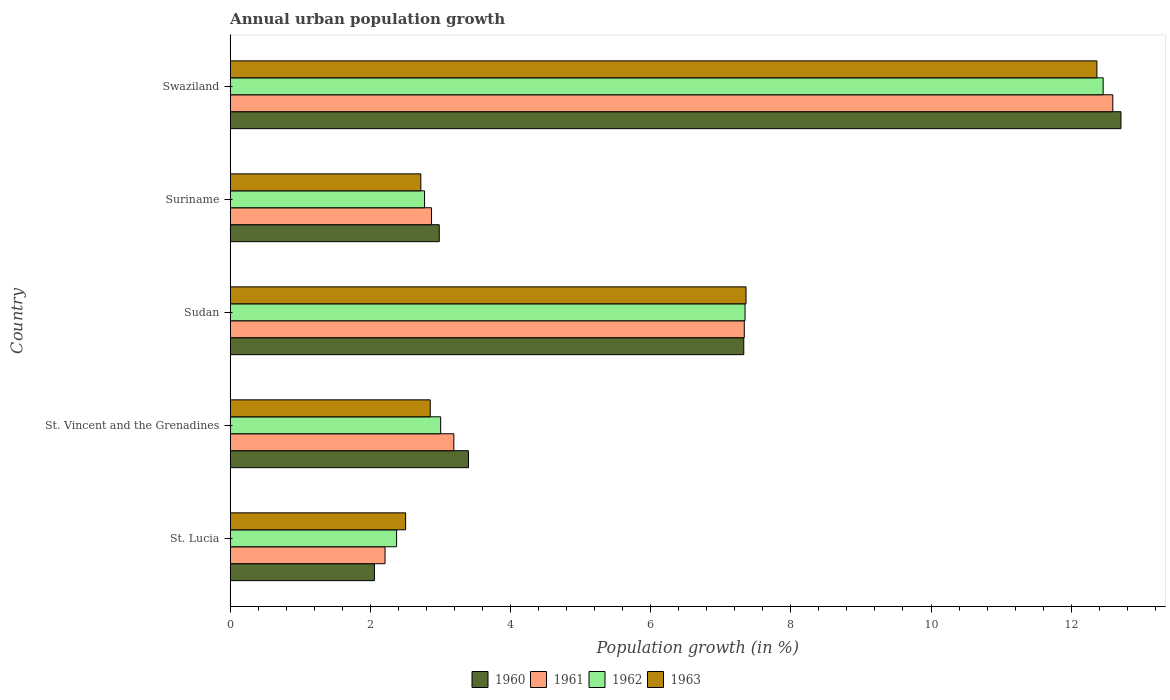How many different coloured bars are there?
Your response must be concise. 4. Are the number of bars per tick equal to the number of legend labels?
Offer a very short reply. Yes. Are the number of bars on each tick of the Y-axis equal?
Your answer should be very brief. Yes. How many bars are there on the 3rd tick from the bottom?
Offer a terse response. 4. What is the label of the 2nd group of bars from the top?
Your response must be concise. Suriname. What is the percentage of urban population growth in 1961 in St. Lucia?
Offer a very short reply. 2.21. Across all countries, what is the maximum percentage of urban population growth in 1960?
Your response must be concise. 12.71. Across all countries, what is the minimum percentage of urban population growth in 1960?
Provide a short and direct response. 2.06. In which country was the percentage of urban population growth in 1961 maximum?
Provide a short and direct response. Swaziland. In which country was the percentage of urban population growth in 1961 minimum?
Offer a terse response. St. Lucia. What is the total percentage of urban population growth in 1960 in the graph?
Your answer should be very brief. 28.48. What is the difference between the percentage of urban population growth in 1962 in Suriname and that in Swaziland?
Keep it short and to the point. -9.68. What is the difference between the percentage of urban population growth in 1962 in St. Vincent and the Grenadines and the percentage of urban population growth in 1963 in Swaziland?
Your answer should be compact. -9.36. What is the average percentage of urban population growth in 1960 per country?
Provide a short and direct response. 5.7. What is the difference between the percentage of urban population growth in 1961 and percentage of urban population growth in 1963 in St. Lucia?
Your answer should be compact. -0.29. What is the ratio of the percentage of urban population growth in 1961 in St. Vincent and the Grenadines to that in Sudan?
Offer a very short reply. 0.44. Is the percentage of urban population growth in 1963 in Sudan less than that in Suriname?
Your answer should be compact. No. What is the difference between the highest and the second highest percentage of urban population growth in 1963?
Offer a very short reply. 5.01. What is the difference between the highest and the lowest percentage of urban population growth in 1963?
Your answer should be compact. 9.86. In how many countries, is the percentage of urban population growth in 1961 greater than the average percentage of urban population growth in 1961 taken over all countries?
Provide a short and direct response. 2. Is the sum of the percentage of urban population growth in 1962 in St. Lucia and Sudan greater than the maximum percentage of urban population growth in 1963 across all countries?
Your response must be concise. No. Is it the case that in every country, the sum of the percentage of urban population growth in 1963 and percentage of urban population growth in 1962 is greater than the sum of percentage of urban population growth in 1961 and percentage of urban population growth in 1960?
Your answer should be very brief. No. What does the 4th bar from the top in Sudan represents?
Give a very brief answer. 1960. How many bars are there?
Give a very brief answer. 20. Are all the bars in the graph horizontal?
Make the answer very short. Yes. How many countries are there in the graph?
Offer a very short reply. 5. Where does the legend appear in the graph?
Your response must be concise. Bottom center. What is the title of the graph?
Provide a short and direct response. Annual urban population growth. Does "1980" appear as one of the legend labels in the graph?
Offer a terse response. No. What is the label or title of the X-axis?
Your response must be concise. Population growth (in %). What is the Population growth (in %) in 1960 in St. Lucia?
Offer a terse response. 2.06. What is the Population growth (in %) in 1961 in St. Lucia?
Offer a terse response. 2.21. What is the Population growth (in %) in 1962 in St. Lucia?
Ensure brevity in your answer.  2.37. What is the Population growth (in %) in 1963 in St. Lucia?
Provide a succinct answer. 2.5. What is the Population growth (in %) of 1960 in St. Vincent and the Grenadines?
Your response must be concise. 3.4. What is the Population growth (in %) in 1961 in St. Vincent and the Grenadines?
Make the answer very short. 3.19. What is the Population growth (in %) in 1962 in St. Vincent and the Grenadines?
Make the answer very short. 3. What is the Population growth (in %) of 1963 in St. Vincent and the Grenadines?
Ensure brevity in your answer.  2.85. What is the Population growth (in %) in 1960 in Sudan?
Your answer should be compact. 7.33. What is the Population growth (in %) of 1961 in Sudan?
Make the answer very short. 7.34. What is the Population growth (in %) of 1962 in Sudan?
Give a very brief answer. 7.35. What is the Population growth (in %) in 1963 in Sudan?
Give a very brief answer. 7.36. What is the Population growth (in %) in 1960 in Suriname?
Your answer should be compact. 2.98. What is the Population growth (in %) of 1961 in Suriname?
Make the answer very short. 2.87. What is the Population growth (in %) in 1962 in Suriname?
Offer a terse response. 2.77. What is the Population growth (in %) in 1963 in Suriname?
Your answer should be very brief. 2.72. What is the Population growth (in %) in 1960 in Swaziland?
Offer a terse response. 12.71. What is the Population growth (in %) in 1961 in Swaziland?
Offer a very short reply. 12.59. What is the Population growth (in %) of 1962 in Swaziland?
Give a very brief answer. 12.46. What is the Population growth (in %) in 1963 in Swaziland?
Your response must be concise. 12.37. Across all countries, what is the maximum Population growth (in %) in 1960?
Your response must be concise. 12.71. Across all countries, what is the maximum Population growth (in %) of 1961?
Ensure brevity in your answer.  12.59. Across all countries, what is the maximum Population growth (in %) in 1962?
Make the answer very short. 12.46. Across all countries, what is the maximum Population growth (in %) of 1963?
Provide a short and direct response. 12.37. Across all countries, what is the minimum Population growth (in %) of 1960?
Offer a very short reply. 2.06. Across all countries, what is the minimum Population growth (in %) of 1961?
Ensure brevity in your answer.  2.21. Across all countries, what is the minimum Population growth (in %) of 1962?
Your response must be concise. 2.37. Across all countries, what is the minimum Population growth (in %) in 1963?
Ensure brevity in your answer.  2.5. What is the total Population growth (in %) of 1960 in the graph?
Provide a succinct answer. 28.48. What is the total Population growth (in %) of 1961 in the graph?
Your response must be concise. 28.2. What is the total Population growth (in %) in 1962 in the graph?
Keep it short and to the point. 27.95. What is the total Population growth (in %) of 1963 in the graph?
Give a very brief answer. 27.81. What is the difference between the Population growth (in %) in 1960 in St. Lucia and that in St. Vincent and the Grenadines?
Provide a succinct answer. -1.34. What is the difference between the Population growth (in %) of 1961 in St. Lucia and that in St. Vincent and the Grenadines?
Provide a succinct answer. -0.98. What is the difference between the Population growth (in %) of 1962 in St. Lucia and that in St. Vincent and the Grenadines?
Your answer should be compact. -0.63. What is the difference between the Population growth (in %) of 1963 in St. Lucia and that in St. Vincent and the Grenadines?
Your response must be concise. -0.35. What is the difference between the Population growth (in %) of 1960 in St. Lucia and that in Sudan?
Provide a short and direct response. -5.27. What is the difference between the Population growth (in %) in 1961 in St. Lucia and that in Sudan?
Keep it short and to the point. -5.13. What is the difference between the Population growth (in %) in 1962 in St. Lucia and that in Sudan?
Offer a terse response. -4.97. What is the difference between the Population growth (in %) of 1963 in St. Lucia and that in Sudan?
Make the answer very short. -4.86. What is the difference between the Population growth (in %) in 1960 in St. Lucia and that in Suriname?
Give a very brief answer. -0.93. What is the difference between the Population growth (in %) of 1961 in St. Lucia and that in Suriname?
Provide a succinct answer. -0.66. What is the difference between the Population growth (in %) in 1962 in St. Lucia and that in Suriname?
Your answer should be very brief. -0.4. What is the difference between the Population growth (in %) of 1963 in St. Lucia and that in Suriname?
Your response must be concise. -0.22. What is the difference between the Population growth (in %) in 1960 in St. Lucia and that in Swaziland?
Your response must be concise. -10.65. What is the difference between the Population growth (in %) in 1961 in St. Lucia and that in Swaziland?
Offer a very short reply. -10.38. What is the difference between the Population growth (in %) in 1962 in St. Lucia and that in Swaziland?
Offer a very short reply. -10.08. What is the difference between the Population growth (in %) in 1963 in St. Lucia and that in Swaziland?
Your answer should be very brief. -9.86. What is the difference between the Population growth (in %) of 1960 in St. Vincent and the Grenadines and that in Sudan?
Ensure brevity in your answer.  -3.93. What is the difference between the Population growth (in %) of 1961 in St. Vincent and the Grenadines and that in Sudan?
Offer a terse response. -4.14. What is the difference between the Population growth (in %) in 1962 in St. Vincent and the Grenadines and that in Sudan?
Provide a short and direct response. -4.34. What is the difference between the Population growth (in %) of 1963 in St. Vincent and the Grenadines and that in Sudan?
Your response must be concise. -4.51. What is the difference between the Population growth (in %) of 1960 in St. Vincent and the Grenadines and that in Suriname?
Provide a succinct answer. 0.42. What is the difference between the Population growth (in %) in 1961 in St. Vincent and the Grenadines and that in Suriname?
Provide a succinct answer. 0.32. What is the difference between the Population growth (in %) in 1962 in St. Vincent and the Grenadines and that in Suriname?
Provide a succinct answer. 0.23. What is the difference between the Population growth (in %) in 1963 in St. Vincent and the Grenadines and that in Suriname?
Give a very brief answer. 0.13. What is the difference between the Population growth (in %) in 1960 in St. Vincent and the Grenadines and that in Swaziland?
Provide a succinct answer. -9.31. What is the difference between the Population growth (in %) in 1961 in St. Vincent and the Grenadines and that in Swaziland?
Your response must be concise. -9.4. What is the difference between the Population growth (in %) of 1962 in St. Vincent and the Grenadines and that in Swaziland?
Your answer should be compact. -9.45. What is the difference between the Population growth (in %) in 1963 in St. Vincent and the Grenadines and that in Swaziland?
Your answer should be very brief. -9.51. What is the difference between the Population growth (in %) of 1960 in Sudan and that in Suriname?
Your answer should be compact. 4.35. What is the difference between the Population growth (in %) of 1961 in Sudan and that in Suriname?
Make the answer very short. 4.46. What is the difference between the Population growth (in %) of 1962 in Sudan and that in Suriname?
Give a very brief answer. 4.57. What is the difference between the Population growth (in %) in 1963 in Sudan and that in Suriname?
Your response must be concise. 4.64. What is the difference between the Population growth (in %) of 1960 in Sudan and that in Swaziland?
Your response must be concise. -5.38. What is the difference between the Population growth (in %) in 1961 in Sudan and that in Swaziland?
Your answer should be compact. -5.26. What is the difference between the Population growth (in %) in 1962 in Sudan and that in Swaziland?
Offer a terse response. -5.11. What is the difference between the Population growth (in %) in 1963 in Sudan and that in Swaziland?
Your answer should be compact. -5.01. What is the difference between the Population growth (in %) of 1960 in Suriname and that in Swaziland?
Offer a very short reply. -9.73. What is the difference between the Population growth (in %) in 1961 in Suriname and that in Swaziland?
Offer a very short reply. -9.72. What is the difference between the Population growth (in %) in 1962 in Suriname and that in Swaziland?
Offer a terse response. -9.68. What is the difference between the Population growth (in %) in 1963 in Suriname and that in Swaziland?
Give a very brief answer. -9.65. What is the difference between the Population growth (in %) in 1960 in St. Lucia and the Population growth (in %) in 1961 in St. Vincent and the Grenadines?
Offer a terse response. -1.13. What is the difference between the Population growth (in %) in 1960 in St. Lucia and the Population growth (in %) in 1962 in St. Vincent and the Grenadines?
Provide a short and direct response. -0.95. What is the difference between the Population growth (in %) in 1960 in St. Lucia and the Population growth (in %) in 1963 in St. Vincent and the Grenadines?
Keep it short and to the point. -0.8. What is the difference between the Population growth (in %) of 1961 in St. Lucia and the Population growth (in %) of 1962 in St. Vincent and the Grenadines?
Make the answer very short. -0.79. What is the difference between the Population growth (in %) of 1961 in St. Lucia and the Population growth (in %) of 1963 in St. Vincent and the Grenadines?
Make the answer very short. -0.65. What is the difference between the Population growth (in %) of 1962 in St. Lucia and the Population growth (in %) of 1963 in St. Vincent and the Grenadines?
Provide a short and direct response. -0.48. What is the difference between the Population growth (in %) of 1960 in St. Lucia and the Population growth (in %) of 1961 in Sudan?
Give a very brief answer. -5.28. What is the difference between the Population growth (in %) in 1960 in St. Lucia and the Population growth (in %) in 1962 in Sudan?
Offer a terse response. -5.29. What is the difference between the Population growth (in %) in 1960 in St. Lucia and the Population growth (in %) in 1963 in Sudan?
Give a very brief answer. -5.3. What is the difference between the Population growth (in %) of 1961 in St. Lucia and the Population growth (in %) of 1962 in Sudan?
Ensure brevity in your answer.  -5.14. What is the difference between the Population growth (in %) of 1961 in St. Lucia and the Population growth (in %) of 1963 in Sudan?
Offer a very short reply. -5.15. What is the difference between the Population growth (in %) in 1962 in St. Lucia and the Population growth (in %) in 1963 in Sudan?
Offer a terse response. -4.99. What is the difference between the Population growth (in %) of 1960 in St. Lucia and the Population growth (in %) of 1961 in Suriname?
Keep it short and to the point. -0.81. What is the difference between the Population growth (in %) of 1960 in St. Lucia and the Population growth (in %) of 1962 in Suriname?
Ensure brevity in your answer.  -0.72. What is the difference between the Population growth (in %) in 1960 in St. Lucia and the Population growth (in %) in 1963 in Suriname?
Make the answer very short. -0.66. What is the difference between the Population growth (in %) of 1961 in St. Lucia and the Population growth (in %) of 1962 in Suriname?
Give a very brief answer. -0.56. What is the difference between the Population growth (in %) of 1961 in St. Lucia and the Population growth (in %) of 1963 in Suriname?
Your answer should be very brief. -0.51. What is the difference between the Population growth (in %) of 1962 in St. Lucia and the Population growth (in %) of 1963 in Suriname?
Make the answer very short. -0.35. What is the difference between the Population growth (in %) of 1960 in St. Lucia and the Population growth (in %) of 1961 in Swaziland?
Offer a very short reply. -10.54. What is the difference between the Population growth (in %) of 1960 in St. Lucia and the Population growth (in %) of 1962 in Swaziland?
Keep it short and to the point. -10.4. What is the difference between the Population growth (in %) in 1960 in St. Lucia and the Population growth (in %) in 1963 in Swaziland?
Your answer should be compact. -10.31. What is the difference between the Population growth (in %) of 1961 in St. Lucia and the Population growth (in %) of 1962 in Swaziland?
Offer a very short reply. -10.25. What is the difference between the Population growth (in %) in 1961 in St. Lucia and the Population growth (in %) in 1963 in Swaziland?
Provide a succinct answer. -10.16. What is the difference between the Population growth (in %) of 1962 in St. Lucia and the Population growth (in %) of 1963 in Swaziland?
Your answer should be very brief. -9.99. What is the difference between the Population growth (in %) in 1960 in St. Vincent and the Grenadines and the Population growth (in %) in 1961 in Sudan?
Keep it short and to the point. -3.94. What is the difference between the Population growth (in %) of 1960 in St. Vincent and the Grenadines and the Population growth (in %) of 1962 in Sudan?
Your answer should be compact. -3.95. What is the difference between the Population growth (in %) in 1960 in St. Vincent and the Grenadines and the Population growth (in %) in 1963 in Sudan?
Your answer should be compact. -3.96. What is the difference between the Population growth (in %) of 1961 in St. Vincent and the Grenadines and the Population growth (in %) of 1962 in Sudan?
Offer a terse response. -4.16. What is the difference between the Population growth (in %) of 1961 in St. Vincent and the Grenadines and the Population growth (in %) of 1963 in Sudan?
Your answer should be compact. -4.17. What is the difference between the Population growth (in %) of 1962 in St. Vincent and the Grenadines and the Population growth (in %) of 1963 in Sudan?
Provide a short and direct response. -4.36. What is the difference between the Population growth (in %) in 1960 in St. Vincent and the Grenadines and the Population growth (in %) in 1961 in Suriname?
Your answer should be very brief. 0.53. What is the difference between the Population growth (in %) of 1960 in St. Vincent and the Grenadines and the Population growth (in %) of 1962 in Suriname?
Give a very brief answer. 0.63. What is the difference between the Population growth (in %) of 1960 in St. Vincent and the Grenadines and the Population growth (in %) of 1963 in Suriname?
Keep it short and to the point. 0.68. What is the difference between the Population growth (in %) of 1961 in St. Vincent and the Grenadines and the Population growth (in %) of 1962 in Suriname?
Offer a very short reply. 0.42. What is the difference between the Population growth (in %) in 1961 in St. Vincent and the Grenadines and the Population growth (in %) in 1963 in Suriname?
Provide a succinct answer. 0.47. What is the difference between the Population growth (in %) in 1962 in St. Vincent and the Grenadines and the Population growth (in %) in 1963 in Suriname?
Make the answer very short. 0.28. What is the difference between the Population growth (in %) in 1960 in St. Vincent and the Grenadines and the Population growth (in %) in 1961 in Swaziland?
Your answer should be compact. -9.19. What is the difference between the Population growth (in %) of 1960 in St. Vincent and the Grenadines and the Population growth (in %) of 1962 in Swaziland?
Offer a terse response. -9.06. What is the difference between the Population growth (in %) of 1960 in St. Vincent and the Grenadines and the Population growth (in %) of 1963 in Swaziland?
Your answer should be compact. -8.97. What is the difference between the Population growth (in %) in 1961 in St. Vincent and the Grenadines and the Population growth (in %) in 1962 in Swaziland?
Offer a very short reply. -9.26. What is the difference between the Population growth (in %) in 1961 in St. Vincent and the Grenadines and the Population growth (in %) in 1963 in Swaziland?
Keep it short and to the point. -9.18. What is the difference between the Population growth (in %) of 1962 in St. Vincent and the Grenadines and the Population growth (in %) of 1963 in Swaziland?
Your answer should be very brief. -9.36. What is the difference between the Population growth (in %) of 1960 in Sudan and the Population growth (in %) of 1961 in Suriname?
Provide a short and direct response. 4.46. What is the difference between the Population growth (in %) in 1960 in Sudan and the Population growth (in %) in 1962 in Suriname?
Offer a terse response. 4.56. What is the difference between the Population growth (in %) in 1960 in Sudan and the Population growth (in %) in 1963 in Suriname?
Your answer should be very brief. 4.61. What is the difference between the Population growth (in %) of 1961 in Sudan and the Population growth (in %) of 1962 in Suriname?
Give a very brief answer. 4.56. What is the difference between the Population growth (in %) in 1961 in Sudan and the Population growth (in %) in 1963 in Suriname?
Keep it short and to the point. 4.62. What is the difference between the Population growth (in %) of 1962 in Sudan and the Population growth (in %) of 1963 in Suriname?
Your answer should be very brief. 4.63. What is the difference between the Population growth (in %) of 1960 in Sudan and the Population growth (in %) of 1961 in Swaziland?
Ensure brevity in your answer.  -5.27. What is the difference between the Population growth (in %) of 1960 in Sudan and the Population growth (in %) of 1962 in Swaziland?
Give a very brief answer. -5.13. What is the difference between the Population growth (in %) in 1960 in Sudan and the Population growth (in %) in 1963 in Swaziland?
Your answer should be very brief. -5.04. What is the difference between the Population growth (in %) in 1961 in Sudan and the Population growth (in %) in 1962 in Swaziland?
Ensure brevity in your answer.  -5.12. What is the difference between the Population growth (in %) of 1961 in Sudan and the Population growth (in %) of 1963 in Swaziland?
Keep it short and to the point. -5.03. What is the difference between the Population growth (in %) of 1962 in Sudan and the Population growth (in %) of 1963 in Swaziland?
Give a very brief answer. -5.02. What is the difference between the Population growth (in %) in 1960 in Suriname and the Population growth (in %) in 1961 in Swaziland?
Provide a succinct answer. -9.61. What is the difference between the Population growth (in %) of 1960 in Suriname and the Population growth (in %) of 1962 in Swaziland?
Make the answer very short. -9.47. What is the difference between the Population growth (in %) of 1960 in Suriname and the Population growth (in %) of 1963 in Swaziland?
Make the answer very short. -9.38. What is the difference between the Population growth (in %) in 1961 in Suriname and the Population growth (in %) in 1962 in Swaziland?
Your answer should be compact. -9.58. What is the difference between the Population growth (in %) in 1961 in Suriname and the Population growth (in %) in 1963 in Swaziland?
Make the answer very short. -9.49. What is the difference between the Population growth (in %) of 1962 in Suriname and the Population growth (in %) of 1963 in Swaziland?
Offer a very short reply. -9.59. What is the average Population growth (in %) in 1960 per country?
Offer a very short reply. 5.7. What is the average Population growth (in %) of 1961 per country?
Your answer should be compact. 5.64. What is the average Population growth (in %) in 1962 per country?
Offer a terse response. 5.59. What is the average Population growth (in %) of 1963 per country?
Provide a short and direct response. 5.56. What is the difference between the Population growth (in %) in 1960 and Population growth (in %) in 1961 in St. Lucia?
Provide a succinct answer. -0.15. What is the difference between the Population growth (in %) of 1960 and Population growth (in %) of 1962 in St. Lucia?
Make the answer very short. -0.32. What is the difference between the Population growth (in %) in 1960 and Population growth (in %) in 1963 in St. Lucia?
Keep it short and to the point. -0.45. What is the difference between the Population growth (in %) in 1961 and Population growth (in %) in 1962 in St. Lucia?
Ensure brevity in your answer.  -0.17. What is the difference between the Population growth (in %) in 1961 and Population growth (in %) in 1963 in St. Lucia?
Your response must be concise. -0.29. What is the difference between the Population growth (in %) of 1962 and Population growth (in %) of 1963 in St. Lucia?
Keep it short and to the point. -0.13. What is the difference between the Population growth (in %) in 1960 and Population growth (in %) in 1961 in St. Vincent and the Grenadines?
Offer a terse response. 0.21. What is the difference between the Population growth (in %) in 1960 and Population growth (in %) in 1962 in St. Vincent and the Grenadines?
Provide a succinct answer. 0.4. What is the difference between the Population growth (in %) of 1960 and Population growth (in %) of 1963 in St. Vincent and the Grenadines?
Keep it short and to the point. 0.55. What is the difference between the Population growth (in %) in 1961 and Population growth (in %) in 1962 in St. Vincent and the Grenadines?
Offer a terse response. 0.19. What is the difference between the Population growth (in %) of 1961 and Population growth (in %) of 1963 in St. Vincent and the Grenadines?
Your response must be concise. 0.34. What is the difference between the Population growth (in %) in 1962 and Population growth (in %) in 1963 in St. Vincent and the Grenadines?
Offer a terse response. 0.15. What is the difference between the Population growth (in %) of 1960 and Population growth (in %) of 1961 in Sudan?
Your answer should be compact. -0.01. What is the difference between the Population growth (in %) in 1960 and Population growth (in %) in 1962 in Sudan?
Provide a short and direct response. -0.02. What is the difference between the Population growth (in %) of 1960 and Population growth (in %) of 1963 in Sudan?
Your answer should be very brief. -0.03. What is the difference between the Population growth (in %) in 1961 and Population growth (in %) in 1962 in Sudan?
Make the answer very short. -0.01. What is the difference between the Population growth (in %) of 1961 and Population growth (in %) of 1963 in Sudan?
Offer a very short reply. -0.02. What is the difference between the Population growth (in %) in 1962 and Population growth (in %) in 1963 in Sudan?
Your answer should be very brief. -0.01. What is the difference between the Population growth (in %) of 1960 and Population growth (in %) of 1961 in Suriname?
Your response must be concise. 0.11. What is the difference between the Population growth (in %) in 1960 and Population growth (in %) in 1962 in Suriname?
Your response must be concise. 0.21. What is the difference between the Population growth (in %) of 1960 and Population growth (in %) of 1963 in Suriname?
Provide a short and direct response. 0.26. What is the difference between the Population growth (in %) in 1961 and Population growth (in %) in 1962 in Suriname?
Ensure brevity in your answer.  0.1. What is the difference between the Population growth (in %) in 1961 and Population growth (in %) in 1963 in Suriname?
Keep it short and to the point. 0.15. What is the difference between the Population growth (in %) of 1962 and Population growth (in %) of 1963 in Suriname?
Provide a short and direct response. 0.05. What is the difference between the Population growth (in %) of 1960 and Population growth (in %) of 1961 in Swaziland?
Your answer should be very brief. 0.12. What is the difference between the Population growth (in %) in 1960 and Population growth (in %) in 1962 in Swaziland?
Your response must be concise. 0.25. What is the difference between the Population growth (in %) of 1960 and Population growth (in %) of 1963 in Swaziland?
Offer a very short reply. 0.34. What is the difference between the Population growth (in %) in 1961 and Population growth (in %) in 1962 in Swaziland?
Offer a very short reply. 0.14. What is the difference between the Population growth (in %) in 1961 and Population growth (in %) in 1963 in Swaziland?
Provide a short and direct response. 0.23. What is the difference between the Population growth (in %) of 1962 and Population growth (in %) of 1963 in Swaziland?
Ensure brevity in your answer.  0.09. What is the ratio of the Population growth (in %) of 1960 in St. Lucia to that in St. Vincent and the Grenadines?
Ensure brevity in your answer.  0.61. What is the ratio of the Population growth (in %) of 1961 in St. Lucia to that in St. Vincent and the Grenadines?
Ensure brevity in your answer.  0.69. What is the ratio of the Population growth (in %) in 1962 in St. Lucia to that in St. Vincent and the Grenadines?
Provide a short and direct response. 0.79. What is the ratio of the Population growth (in %) of 1963 in St. Lucia to that in St. Vincent and the Grenadines?
Your answer should be very brief. 0.88. What is the ratio of the Population growth (in %) in 1960 in St. Lucia to that in Sudan?
Your answer should be very brief. 0.28. What is the ratio of the Population growth (in %) of 1961 in St. Lucia to that in Sudan?
Ensure brevity in your answer.  0.3. What is the ratio of the Population growth (in %) in 1962 in St. Lucia to that in Sudan?
Provide a short and direct response. 0.32. What is the ratio of the Population growth (in %) in 1963 in St. Lucia to that in Sudan?
Make the answer very short. 0.34. What is the ratio of the Population growth (in %) of 1960 in St. Lucia to that in Suriname?
Provide a short and direct response. 0.69. What is the ratio of the Population growth (in %) in 1961 in St. Lucia to that in Suriname?
Keep it short and to the point. 0.77. What is the ratio of the Population growth (in %) in 1962 in St. Lucia to that in Suriname?
Provide a short and direct response. 0.86. What is the ratio of the Population growth (in %) in 1963 in St. Lucia to that in Suriname?
Your answer should be compact. 0.92. What is the ratio of the Population growth (in %) of 1960 in St. Lucia to that in Swaziland?
Give a very brief answer. 0.16. What is the ratio of the Population growth (in %) in 1961 in St. Lucia to that in Swaziland?
Offer a very short reply. 0.18. What is the ratio of the Population growth (in %) of 1962 in St. Lucia to that in Swaziland?
Provide a short and direct response. 0.19. What is the ratio of the Population growth (in %) in 1963 in St. Lucia to that in Swaziland?
Keep it short and to the point. 0.2. What is the ratio of the Population growth (in %) in 1960 in St. Vincent and the Grenadines to that in Sudan?
Keep it short and to the point. 0.46. What is the ratio of the Population growth (in %) of 1961 in St. Vincent and the Grenadines to that in Sudan?
Your answer should be compact. 0.44. What is the ratio of the Population growth (in %) of 1962 in St. Vincent and the Grenadines to that in Sudan?
Provide a short and direct response. 0.41. What is the ratio of the Population growth (in %) in 1963 in St. Vincent and the Grenadines to that in Sudan?
Provide a short and direct response. 0.39. What is the ratio of the Population growth (in %) in 1960 in St. Vincent and the Grenadines to that in Suriname?
Give a very brief answer. 1.14. What is the ratio of the Population growth (in %) in 1961 in St. Vincent and the Grenadines to that in Suriname?
Keep it short and to the point. 1.11. What is the ratio of the Population growth (in %) of 1962 in St. Vincent and the Grenadines to that in Suriname?
Offer a very short reply. 1.08. What is the ratio of the Population growth (in %) of 1963 in St. Vincent and the Grenadines to that in Suriname?
Keep it short and to the point. 1.05. What is the ratio of the Population growth (in %) of 1960 in St. Vincent and the Grenadines to that in Swaziland?
Your answer should be very brief. 0.27. What is the ratio of the Population growth (in %) in 1961 in St. Vincent and the Grenadines to that in Swaziland?
Make the answer very short. 0.25. What is the ratio of the Population growth (in %) of 1962 in St. Vincent and the Grenadines to that in Swaziland?
Give a very brief answer. 0.24. What is the ratio of the Population growth (in %) in 1963 in St. Vincent and the Grenadines to that in Swaziland?
Your answer should be compact. 0.23. What is the ratio of the Population growth (in %) in 1960 in Sudan to that in Suriname?
Make the answer very short. 2.46. What is the ratio of the Population growth (in %) of 1961 in Sudan to that in Suriname?
Keep it short and to the point. 2.55. What is the ratio of the Population growth (in %) of 1962 in Sudan to that in Suriname?
Keep it short and to the point. 2.65. What is the ratio of the Population growth (in %) in 1963 in Sudan to that in Suriname?
Give a very brief answer. 2.71. What is the ratio of the Population growth (in %) of 1960 in Sudan to that in Swaziland?
Offer a terse response. 0.58. What is the ratio of the Population growth (in %) of 1961 in Sudan to that in Swaziland?
Provide a succinct answer. 0.58. What is the ratio of the Population growth (in %) in 1962 in Sudan to that in Swaziland?
Your answer should be very brief. 0.59. What is the ratio of the Population growth (in %) in 1963 in Sudan to that in Swaziland?
Your answer should be very brief. 0.6. What is the ratio of the Population growth (in %) in 1960 in Suriname to that in Swaziland?
Provide a short and direct response. 0.23. What is the ratio of the Population growth (in %) of 1961 in Suriname to that in Swaziland?
Make the answer very short. 0.23. What is the ratio of the Population growth (in %) in 1962 in Suriname to that in Swaziland?
Your answer should be very brief. 0.22. What is the ratio of the Population growth (in %) of 1963 in Suriname to that in Swaziland?
Provide a short and direct response. 0.22. What is the difference between the highest and the second highest Population growth (in %) of 1960?
Your answer should be very brief. 5.38. What is the difference between the highest and the second highest Population growth (in %) in 1961?
Make the answer very short. 5.26. What is the difference between the highest and the second highest Population growth (in %) in 1962?
Make the answer very short. 5.11. What is the difference between the highest and the second highest Population growth (in %) in 1963?
Your answer should be compact. 5.01. What is the difference between the highest and the lowest Population growth (in %) of 1960?
Ensure brevity in your answer.  10.65. What is the difference between the highest and the lowest Population growth (in %) of 1961?
Offer a terse response. 10.38. What is the difference between the highest and the lowest Population growth (in %) in 1962?
Your response must be concise. 10.08. What is the difference between the highest and the lowest Population growth (in %) of 1963?
Offer a very short reply. 9.86. 